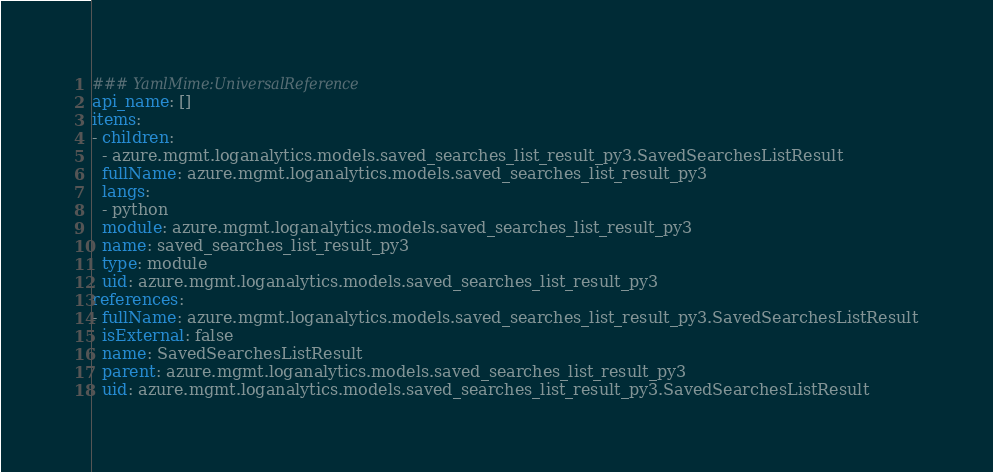Convert code to text. <code><loc_0><loc_0><loc_500><loc_500><_YAML_>### YamlMime:UniversalReference
api_name: []
items:
- children:
  - azure.mgmt.loganalytics.models.saved_searches_list_result_py3.SavedSearchesListResult
  fullName: azure.mgmt.loganalytics.models.saved_searches_list_result_py3
  langs:
  - python
  module: azure.mgmt.loganalytics.models.saved_searches_list_result_py3
  name: saved_searches_list_result_py3
  type: module
  uid: azure.mgmt.loganalytics.models.saved_searches_list_result_py3
references:
- fullName: azure.mgmt.loganalytics.models.saved_searches_list_result_py3.SavedSearchesListResult
  isExternal: false
  name: SavedSearchesListResult
  parent: azure.mgmt.loganalytics.models.saved_searches_list_result_py3
  uid: azure.mgmt.loganalytics.models.saved_searches_list_result_py3.SavedSearchesListResult
</code> 